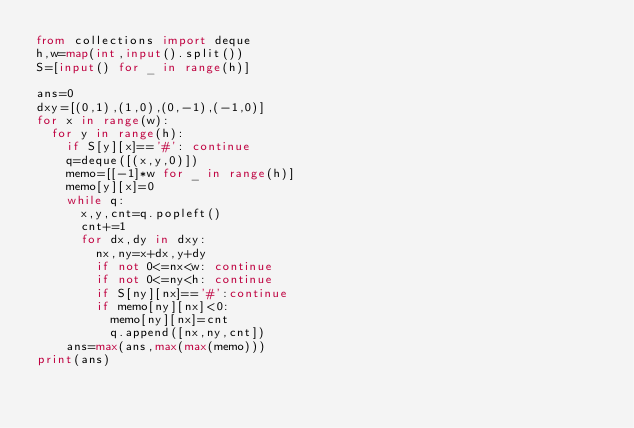Convert code to text. <code><loc_0><loc_0><loc_500><loc_500><_Python_>from collections import deque
h,w=map(int,input().split())
S=[input() for _ in range(h)]

ans=0
dxy=[(0,1),(1,0),(0,-1),(-1,0)]
for x in range(w):
  for y in range(h):
    if S[y][x]=='#': continue
    q=deque([(x,y,0)])
    memo=[[-1]*w for _ in range(h)]
    memo[y][x]=0
    while q:
      x,y,cnt=q.popleft()
      cnt+=1
      for dx,dy in dxy:
        nx,ny=x+dx,y+dy
        if not 0<=nx<w: continue
        if not 0<=ny<h: continue
        if S[ny][nx]=='#':continue
        if memo[ny][nx]<0:
          memo[ny][nx]=cnt
          q.append([nx,ny,cnt])
    ans=max(ans,max(max(memo)))
print(ans)</code> 